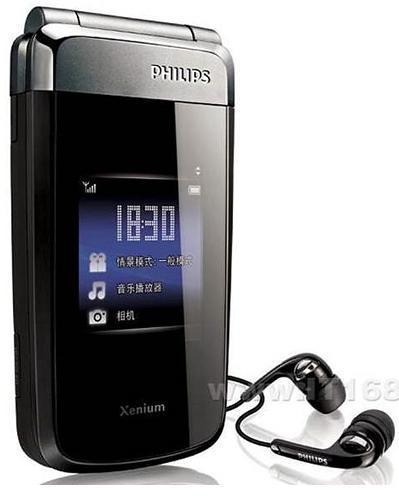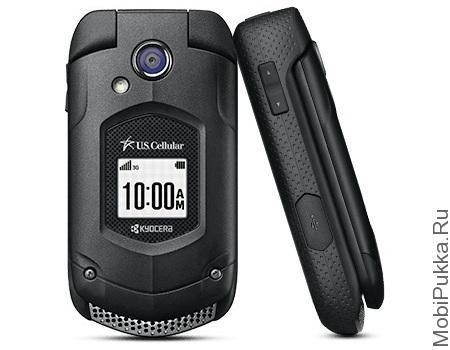The first image is the image on the left, the second image is the image on the right. Given the left and right images, does the statement "At least one image shows the side profile of a phone." hold true? Answer yes or no. Yes. The first image is the image on the left, the second image is the image on the right. Considering the images on both sides, is "There is a total of six flip phones." valid? Answer yes or no. No. 